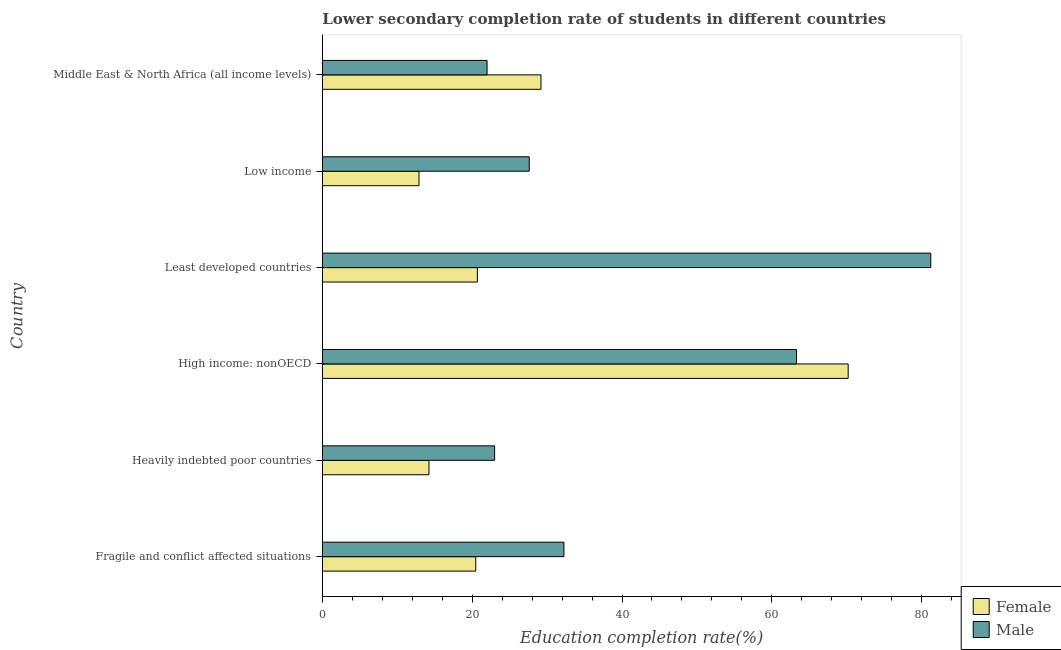How many different coloured bars are there?
Keep it short and to the point. 2. How many groups of bars are there?
Your response must be concise. 6. Are the number of bars per tick equal to the number of legend labels?
Ensure brevity in your answer.  Yes. How many bars are there on the 1st tick from the top?
Ensure brevity in your answer.  2. What is the label of the 1st group of bars from the top?
Give a very brief answer. Middle East & North Africa (all income levels). What is the education completion rate of male students in Low income?
Give a very brief answer. 27.61. Across all countries, what is the maximum education completion rate of male students?
Give a very brief answer. 81.21. Across all countries, what is the minimum education completion rate of male students?
Offer a terse response. 21.99. In which country was the education completion rate of female students maximum?
Your answer should be compact. High income: nonOECD. What is the total education completion rate of female students in the graph?
Your answer should be very brief. 167.68. What is the difference between the education completion rate of male students in High income: nonOECD and that in Low income?
Your answer should be compact. 35.67. What is the difference between the education completion rate of male students in High income: nonOECD and the education completion rate of female students in Middle East & North Africa (all income levels)?
Give a very brief answer. 34.1. What is the average education completion rate of female students per country?
Provide a short and direct response. 27.95. What is the difference between the education completion rate of male students and education completion rate of female students in Middle East & North Africa (all income levels)?
Keep it short and to the point. -7.2. In how many countries, is the education completion rate of female students greater than 24 %?
Your response must be concise. 2. What is the ratio of the education completion rate of male students in Fragile and conflict affected situations to that in High income: nonOECD?
Provide a short and direct response. 0.51. Is the education completion rate of male students in Fragile and conflict affected situations less than that in Low income?
Your answer should be very brief. No. What is the difference between the highest and the second highest education completion rate of female students?
Offer a very short reply. 41. What is the difference between the highest and the lowest education completion rate of male students?
Provide a short and direct response. 59.22. In how many countries, is the education completion rate of female students greater than the average education completion rate of female students taken over all countries?
Provide a succinct answer. 2. What does the 1st bar from the bottom in High income: nonOECD represents?
Keep it short and to the point. Female. How many bars are there?
Your answer should be compact. 12. Are all the bars in the graph horizontal?
Make the answer very short. Yes. How many countries are there in the graph?
Provide a short and direct response. 6. What is the difference between two consecutive major ticks on the X-axis?
Ensure brevity in your answer.  20. Does the graph contain any zero values?
Offer a very short reply. No. Does the graph contain grids?
Give a very brief answer. No. What is the title of the graph?
Offer a terse response. Lower secondary completion rate of students in different countries. Does "Taxes on profits and capital gains" appear as one of the legend labels in the graph?
Provide a succinct answer. No. What is the label or title of the X-axis?
Your answer should be compact. Education completion rate(%). What is the label or title of the Y-axis?
Give a very brief answer. Country. What is the Education completion rate(%) in Female in Fragile and conflict affected situations?
Make the answer very short. 20.48. What is the Education completion rate(%) of Male in Fragile and conflict affected situations?
Make the answer very short. 32.25. What is the Education completion rate(%) in Female in Heavily indebted poor countries?
Make the answer very short. 14.23. What is the Education completion rate(%) in Male in Heavily indebted poor countries?
Your answer should be very brief. 23. What is the Education completion rate(%) of Female in High income: nonOECD?
Ensure brevity in your answer.  70.19. What is the Education completion rate(%) of Male in High income: nonOECD?
Provide a short and direct response. 63.29. What is the Education completion rate(%) in Female in Least developed countries?
Give a very brief answer. 20.69. What is the Education completion rate(%) in Male in Least developed countries?
Your answer should be very brief. 81.21. What is the Education completion rate(%) of Female in Low income?
Offer a terse response. 12.9. What is the Education completion rate(%) of Male in Low income?
Offer a terse response. 27.61. What is the Education completion rate(%) in Female in Middle East & North Africa (all income levels)?
Keep it short and to the point. 29.18. What is the Education completion rate(%) in Male in Middle East & North Africa (all income levels)?
Offer a terse response. 21.99. Across all countries, what is the maximum Education completion rate(%) of Female?
Your answer should be very brief. 70.19. Across all countries, what is the maximum Education completion rate(%) of Male?
Your answer should be compact. 81.21. Across all countries, what is the minimum Education completion rate(%) in Female?
Offer a very short reply. 12.9. Across all countries, what is the minimum Education completion rate(%) of Male?
Provide a short and direct response. 21.99. What is the total Education completion rate(%) in Female in the graph?
Offer a very short reply. 167.68. What is the total Education completion rate(%) in Male in the graph?
Give a very brief answer. 249.34. What is the difference between the Education completion rate(%) in Female in Fragile and conflict affected situations and that in Heavily indebted poor countries?
Give a very brief answer. 6.25. What is the difference between the Education completion rate(%) of Male in Fragile and conflict affected situations and that in Heavily indebted poor countries?
Offer a very short reply. 9.25. What is the difference between the Education completion rate(%) in Female in Fragile and conflict affected situations and that in High income: nonOECD?
Make the answer very short. -49.71. What is the difference between the Education completion rate(%) of Male in Fragile and conflict affected situations and that in High income: nonOECD?
Your response must be concise. -31.04. What is the difference between the Education completion rate(%) of Female in Fragile and conflict affected situations and that in Least developed countries?
Provide a short and direct response. -0.21. What is the difference between the Education completion rate(%) of Male in Fragile and conflict affected situations and that in Least developed countries?
Provide a succinct answer. -48.96. What is the difference between the Education completion rate(%) in Female in Fragile and conflict affected situations and that in Low income?
Provide a succinct answer. 7.58. What is the difference between the Education completion rate(%) in Male in Fragile and conflict affected situations and that in Low income?
Your answer should be very brief. 4.63. What is the difference between the Education completion rate(%) in Female in Fragile and conflict affected situations and that in Middle East & North Africa (all income levels)?
Your response must be concise. -8.7. What is the difference between the Education completion rate(%) in Male in Fragile and conflict affected situations and that in Middle East & North Africa (all income levels)?
Offer a terse response. 10.26. What is the difference between the Education completion rate(%) in Female in Heavily indebted poor countries and that in High income: nonOECD?
Give a very brief answer. -55.95. What is the difference between the Education completion rate(%) of Male in Heavily indebted poor countries and that in High income: nonOECD?
Give a very brief answer. -40.29. What is the difference between the Education completion rate(%) of Female in Heavily indebted poor countries and that in Least developed countries?
Make the answer very short. -6.46. What is the difference between the Education completion rate(%) in Male in Heavily indebted poor countries and that in Least developed countries?
Provide a short and direct response. -58.21. What is the difference between the Education completion rate(%) in Female in Heavily indebted poor countries and that in Low income?
Give a very brief answer. 1.33. What is the difference between the Education completion rate(%) in Male in Heavily indebted poor countries and that in Low income?
Ensure brevity in your answer.  -4.62. What is the difference between the Education completion rate(%) in Female in Heavily indebted poor countries and that in Middle East & North Africa (all income levels)?
Your response must be concise. -14.95. What is the difference between the Education completion rate(%) of Female in High income: nonOECD and that in Least developed countries?
Make the answer very short. 49.49. What is the difference between the Education completion rate(%) in Male in High income: nonOECD and that in Least developed countries?
Offer a terse response. -17.92. What is the difference between the Education completion rate(%) in Female in High income: nonOECD and that in Low income?
Your answer should be very brief. 57.28. What is the difference between the Education completion rate(%) of Male in High income: nonOECD and that in Low income?
Make the answer very short. 35.67. What is the difference between the Education completion rate(%) of Female in High income: nonOECD and that in Middle East & North Africa (all income levels)?
Offer a very short reply. 41. What is the difference between the Education completion rate(%) in Male in High income: nonOECD and that in Middle East & North Africa (all income levels)?
Make the answer very short. 41.3. What is the difference between the Education completion rate(%) in Female in Least developed countries and that in Low income?
Make the answer very short. 7.79. What is the difference between the Education completion rate(%) in Male in Least developed countries and that in Low income?
Ensure brevity in your answer.  53.6. What is the difference between the Education completion rate(%) of Female in Least developed countries and that in Middle East & North Africa (all income levels)?
Your answer should be very brief. -8.49. What is the difference between the Education completion rate(%) in Male in Least developed countries and that in Middle East & North Africa (all income levels)?
Offer a very short reply. 59.22. What is the difference between the Education completion rate(%) of Female in Low income and that in Middle East & North Africa (all income levels)?
Give a very brief answer. -16.28. What is the difference between the Education completion rate(%) of Male in Low income and that in Middle East & North Africa (all income levels)?
Offer a very short reply. 5.62. What is the difference between the Education completion rate(%) of Female in Fragile and conflict affected situations and the Education completion rate(%) of Male in Heavily indebted poor countries?
Keep it short and to the point. -2.52. What is the difference between the Education completion rate(%) of Female in Fragile and conflict affected situations and the Education completion rate(%) of Male in High income: nonOECD?
Give a very brief answer. -42.81. What is the difference between the Education completion rate(%) of Female in Fragile and conflict affected situations and the Education completion rate(%) of Male in Least developed countries?
Make the answer very short. -60.73. What is the difference between the Education completion rate(%) of Female in Fragile and conflict affected situations and the Education completion rate(%) of Male in Low income?
Ensure brevity in your answer.  -7.13. What is the difference between the Education completion rate(%) in Female in Fragile and conflict affected situations and the Education completion rate(%) in Male in Middle East & North Africa (all income levels)?
Provide a short and direct response. -1.51. What is the difference between the Education completion rate(%) of Female in Heavily indebted poor countries and the Education completion rate(%) of Male in High income: nonOECD?
Provide a succinct answer. -49.05. What is the difference between the Education completion rate(%) of Female in Heavily indebted poor countries and the Education completion rate(%) of Male in Least developed countries?
Offer a very short reply. -66.98. What is the difference between the Education completion rate(%) in Female in Heavily indebted poor countries and the Education completion rate(%) in Male in Low income?
Keep it short and to the point. -13.38. What is the difference between the Education completion rate(%) in Female in Heavily indebted poor countries and the Education completion rate(%) in Male in Middle East & North Africa (all income levels)?
Your response must be concise. -7.76. What is the difference between the Education completion rate(%) of Female in High income: nonOECD and the Education completion rate(%) of Male in Least developed countries?
Ensure brevity in your answer.  -11.02. What is the difference between the Education completion rate(%) of Female in High income: nonOECD and the Education completion rate(%) of Male in Low income?
Your answer should be very brief. 42.57. What is the difference between the Education completion rate(%) of Female in High income: nonOECD and the Education completion rate(%) of Male in Middle East & North Africa (all income levels)?
Offer a terse response. 48.2. What is the difference between the Education completion rate(%) in Female in Least developed countries and the Education completion rate(%) in Male in Low income?
Make the answer very short. -6.92. What is the difference between the Education completion rate(%) in Female in Least developed countries and the Education completion rate(%) in Male in Middle East & North Africa (all income levels)?
Give a very brief answer. -1.3. What is the difference between the Education completion rate(%) of Female in Low income and the Education completion rate(%) of Male in Middle East & North Africa (all income levels)?
Keep it short and to the point. -9.09. What is the average Education completion rate(%) in Female per country?
Provide a succinct answer. 27.95. What is the average Education completion rate(%) of Male per country?
Keep it short and to the point. 41.56. What is the difference between the Education completion rate(%) of Female and Education completion rate(%) of Male in Fragile and conflict affected situations?
Provide a succinct answer. -11.77. What is the difference between the Education completion rate(%) of Female and Education completion rate(%) of Male in Heavily indebted poor countries?
Give a very brief answer. -8.76. What is the difference between the Education completion rate(%) of Female and Education completion rate(%) of Male in High income: nonOECD?
Offer a terse response. 6.9. What is the difference between the Education completion rate(%) in Female and Education completion rate(%) in Male in Least developed countries?
Your answer should be compact. -60.52. What is the difference between the Education completion rate(%) of Female and Education completion rate(%) of Male in Low income?
Keep it short and to the point. -14.71. What is the difference between the Education completion rate(%) in Female and Education completion rate(%) in Male in Middle East & North Africa (all income levels)?
Offer a very short reply. 7.19. What is the ratio of the Education completion rate(%) in Female in Fragile and conflict affected situations to that in Heavily indebted poor countries?
Your answer should be compact. 1.44. What is the ratio of the Education completion rate(%) of Male in Fragile and conflict affected situations to that in Heavily indebted poor countries?
Your answer should be very brief. 1.4. What is the ratio of the Education completion rate(%) of Female in Fragile and conflict affected situations to that in High income: nonOECD?
Your response must be concise. 0.29. What is the ratio of the Education completion rate(%) in Male in Fragile and conflict affected situations to that in High income: nonOECD?
Offer a very short reply. 0.51. What is the ratio of the Education completion rate(%) of Male in Fragile and conflict affected situations to that in Least developed countries?
Offer a terse response. 0.4. What is the ratio of the Education completion rate(%) of Female in Fragile and conflict affected situations to that in Low income?
Provide a short and direct response. 1.59. What is the ratio of the Education completion rate(%) in Male in Fragile and conflict affected situations to that in Low income?
Provide a short and direct response. 1.17. What is the ratio of the Education completion rate(%) in Female in Fragile and conflict affected situations to that in Middle East & North Africa (all income levels)?
Keep it short and to the point. 0.7. What is the ratio of the Education completion rate(%) of Male in Fragile and conflict affected situations to that in Middle East & North Africa (all income levels)?
Keep it short and to the point. 1.47. What is the ratio of the Education completion rate(%) of Female in Heavily indebted poor countries to that in High income: nonOECD?
Ensure brevity in your answer.  0.2. What is the ratio of the Education completion rate(%) of Male in Heavily indebted poor countries to that in High income: nonOECD?
Provide a short and direct response. 0.36. What is the ratio of the Education completion rate(%) in Female in Heavily indebted poor countries to that in Least developed countries?
Make the answer very short. 0.69. What is the ratio of the Education completion rate(%) of Male in Heavily indebted poor countries to that in Least developed countries?
Give a very brief answer. 0.28. What is the ratio of the Education completion rate(%) of Female in Heavily indebted poor countries to that in Low income?
Your response must be concise. 1.1. What is the ratio of the Education completion rate(%) of Male in Heavily indebted poor countries to that in Low income?
Keep it short and to the point. 0.83. What is the ratio of the Education completion rate(%) of Female in Heavily indebted poor countries to that in Middle East & North Africa (all income levels)?
Your answer should be very brief. 0.49. What is the ratio of the Education completion rate(%) of Male in Heavily indebted poor countries to that in Middle East & North Africa (all income levels)?
Provide a succinct answer. 1.05. What is the ratio of the Education completion rate(%) of Female in High income: nonOECD to that in Least developed countries?
Make the answer very short. 3.39. What is the ratio of the Education completion rate(%) in Male in High income: nonOECD to that in Least developed countries?
Provide a succinct answer. 0.78. What is the ratio of the Education completion rate(%) in Female in High income: nonOECD to that in Low income?
Provide a short and direct response. 5.44. What is the ratio of the Education completion rate(%) in Male in High income: nonOECD to that in Low income?
Provide a succinct answer. 2.29. What is the ratio of the Education completion rate(%) of Female in High income: nonOECD to that in Middle East & North Africa (all income levels)?
Offer a terse response. 2.4. What is the ratio of the Education completion rate(%) of Male in High income: nonOECD to that in Middle East & North Africa (all income levels)?
Your response must be concise. 2.88. What is the ratio of the Education completion rate(%) in Female in Least developed countries to that in Low income?
Give a very brief answer. 1.6. What is the ratio of the Education completion rate(%) in Male in Least developed countries to that in Low income?
Your response must be concise. 2.94. What is the ratio of the Education completion rate(%) in Female in Least developed countries to that in Middle East & North Africa (all income levels)?
Your answer should be very brief. 0.71. What is the ratio of the Education completion rate(%) in Male in Least developed countries to that in Middle East & North Africa (all income levels)?
Offer a very short reply. 3.69. What is the ratio of the Education completion rate(%) in Female in Low income to that in Middle East & North Africa (all income levels)?
Your response must be concise. 0.44. What is the ratio of the Education completion rate(%) of Male in Low income to that in Middle East & North Africa (all income levels)?
Give a very brief answer. 1.26. What is the difference between the highest and the second highest Education completion rate(%) in Female?
Your response must be concise. 41. What is the difference between the highest and the second highest Education completion rate(%) in Male?
Keep it short and to the point. 17.92. What is the difference between the highest and the lowest Education completion rate(%) in Female?
Make the answer very short. 57.28. What is the difference between the highest and the lowest Education completion rate(%) in Male?
Offer a terse response. 59.22. 